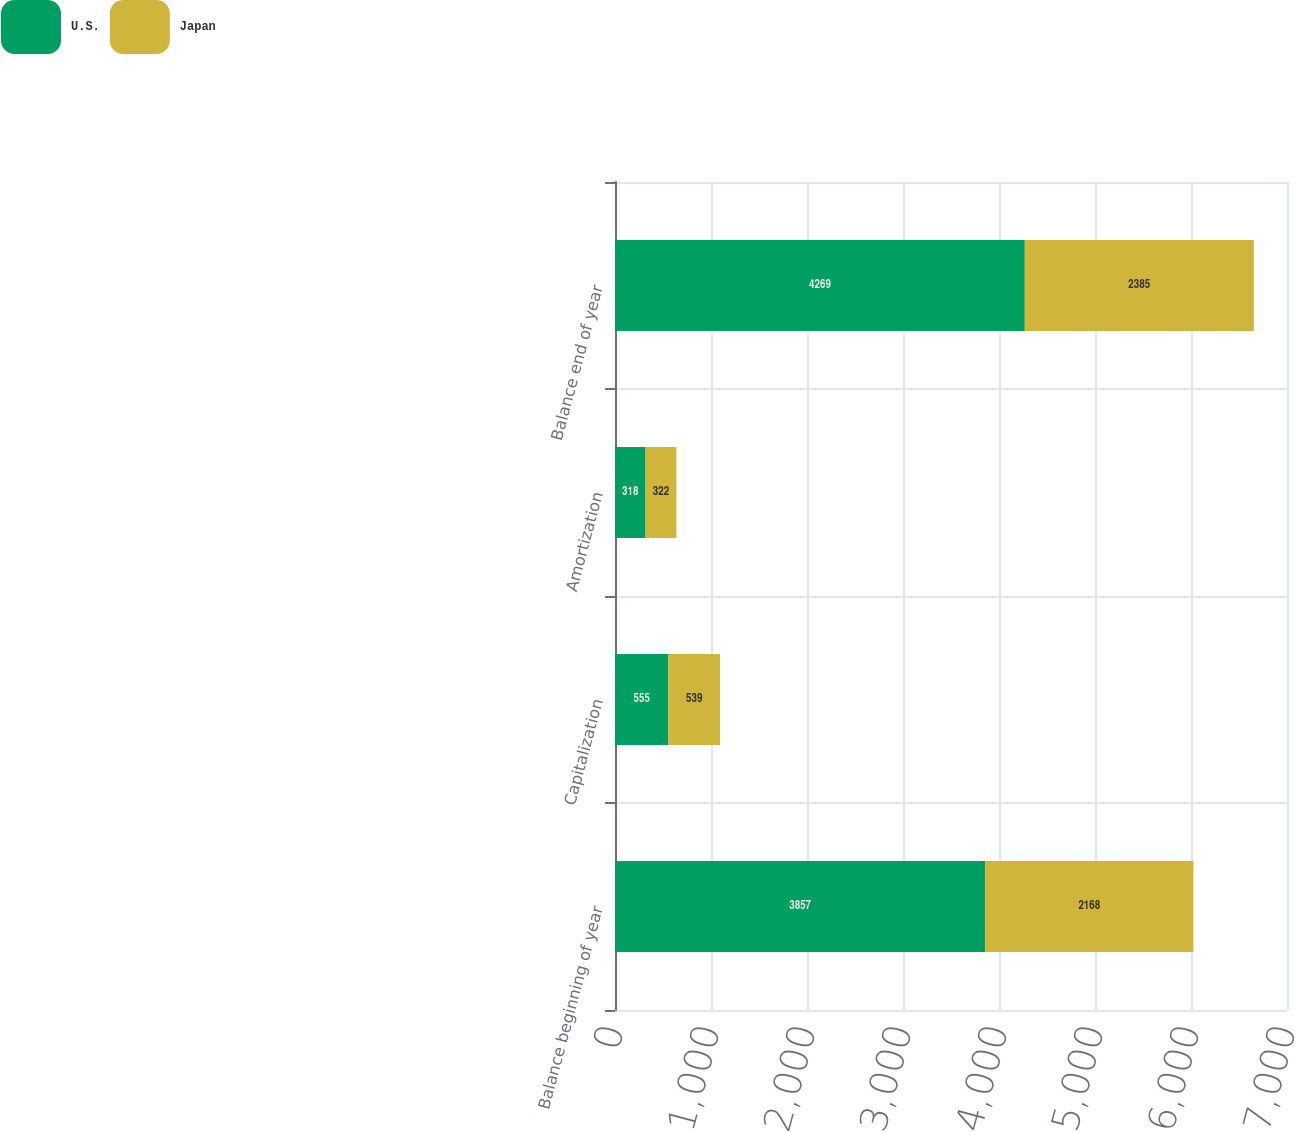Convert chart to OTSL. <chart><loc_0><loc_0><loc_500><loc_500><stacked_bar_chart><ecel><fcel>Balance beginning of year<fcel>Capitalization<fcel>Amortization<fcel>Balance end of year<nl><fcel>U.S.<fcel>3857<fcel>555<fcel>318<fcel>4269<nl><fcel>Japan<fcel>2168<fcel>539<fcel>322<fcel>2385<nl></chart> 